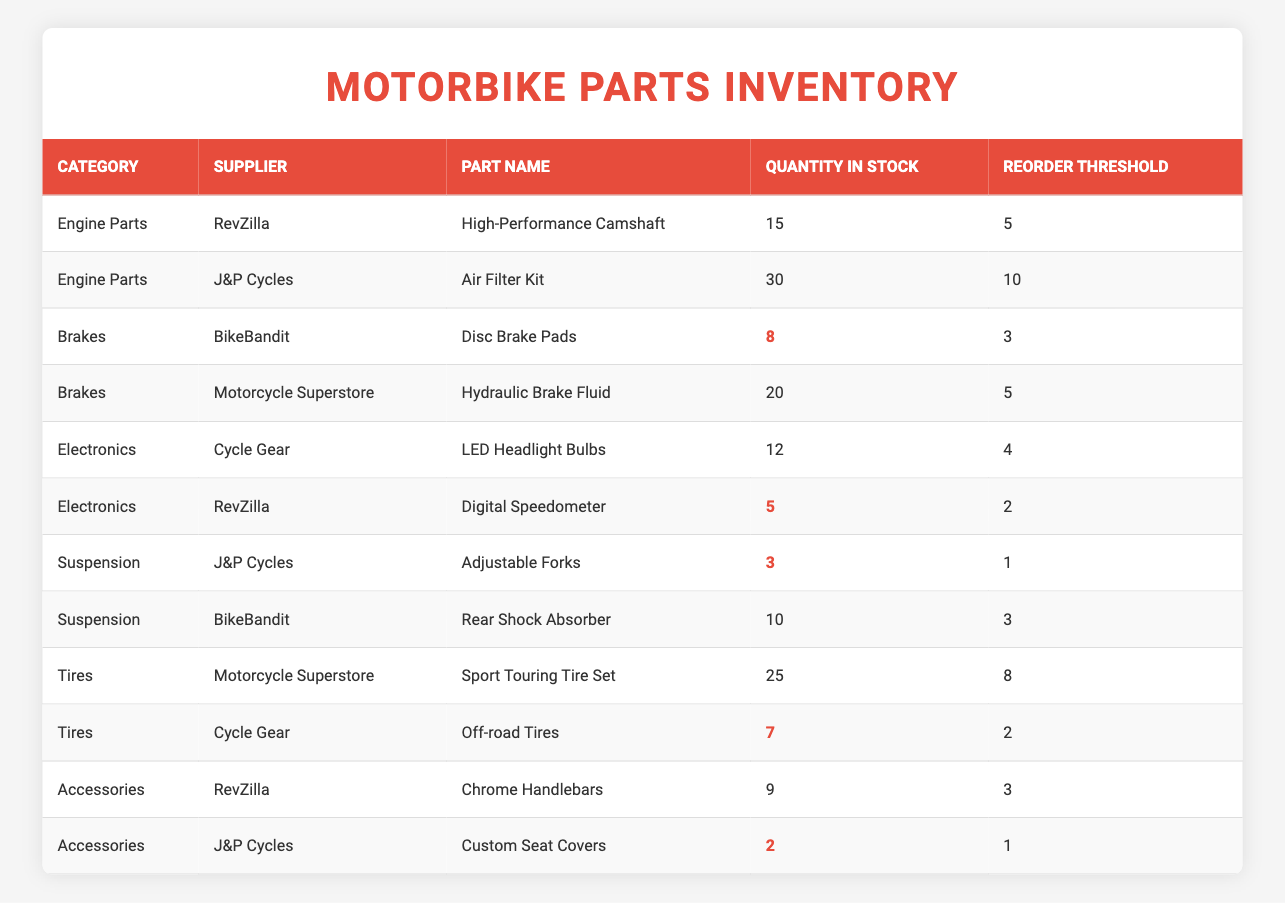What is the quantity in stock for the Digital Speedometer? The table shows that the Digital Speedometer, supplied by RevZilla, has a quantity in stock of 5.
Answer: 5 Which part has the lowest quantity in stock? By examining the quantities in stock for each part, the Custom Seat Covers from J&P Cycles have 2 in stock, which is the lowest amount listed.
Answer: 2 How many Engine Parts are currently in stock across all suppliers? The table lists two Engine Parts: High-Performance Camshaft (15 units) and Air Filter Kit (30 units). To find the total, we add these quantities: 15 + 30 = 45.
Answer: 45 Is the quantity for the Hydraulic Brake Fluid above its reorder threshold? The quantity in stock for Hydraulic Brake Fluid, supplied by Motorcycle Superstore, is 20, while its reorder threshold is 5. Since 20 is greater than 5, the answer is yes.
Answer: Yes What is the total number of parts for the Tires category? The Tires category includes two parts: Sport Touring Tire Set (25 units) and Off-road Tires (7 units). Adding these gives: 25 + 7 = 32 parts in total.
Answer: 32 How many parts have quantities below their reorder thresholds? We review the quantities against their reorder thresholds: Disc Brake Pads (8 vs 3), Digital Speedometer (5 vs 2), Adjustable Forks (3 vs 1), Off-road Tires (7 vs 2), and Custom Seat Covers (2 vs 1). The parts below thresholds are: Digital Speedometer, Adjustable Forks, Off-road Tires, and Custom Seat Covers, totaling 4 parts.
Answer: 4 Which suppliers have parts that need to be reordered? Reviewing the parts against their reorder thresholds, the Digital Speedometer (5 vs 2), Adjustable Forks (3 vs 1), Off-road Tires (7 vs 2), and Custom Seat Covers (2 vs 1) need reordering. The suppliers for these parts are RevZilla, J&P Cycles, Cycle Gear, and J&P Cycles. So, suppliers with parts needing reorder are RevZilla, J&P Cycles, and Cycle Gear.
Answer: RevZilla, J&P Cycles, Cycle Gear What is the average quantity in stock for all parts in the Electronics category? The Electronics category has two parts: LED Headlight Bulbs (12 units) and Digital Speedometer (5 units). To find the average, we sum the quantities: 12 + 5 = 17, then divide by the count of 2 parts: 17 / 2 = 8.5.
Answer: 8.5 How many parts remain in stock after considering the reorder threshold for all categories? We will count how many units are above their reorder thresholds: High-Performance Camshaft (15 > 5), Air Filter Kit (30 > 10), Disc Brake Pads (8 > 3), Hydraulic Brake Fluid (20 > 5), LED Headlight Bulbs (12 > 4), Digital Speedometer (5 = 2), Adjustable Forks (3 = 1), Rear Shock Absorber (10 > 3), Sport Touring Tire Set (25 > 8), Off-road Tires (7 > 2), Chrome Handlebars (9 > 3), and Custom Seat Covers (2 = 1). Adding these quantities gives: 15 + 30 + 8 + 20 + 12 + 5 + 3 + 10 + 25 + 7 + 9 + 2 = 142.
Answer: 142 